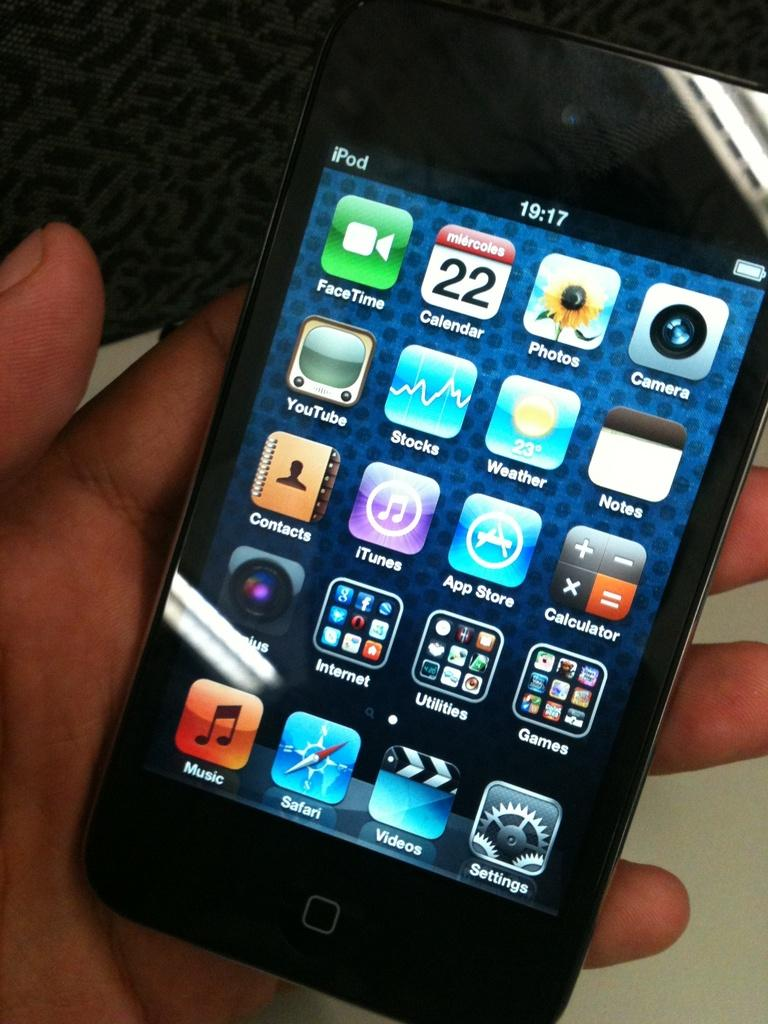Provide a one-sentence caption for the provided image. A black iPod displays many applications including FaceTime, Calendar, Photos, Camera, YouTube, Stocks, Weather and others. 